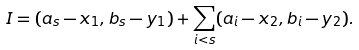<formula> <loc_0><loc_0><loc_500><loc_500>I = ( a _ { s } - x _ { 1 } , b _ { s } - y _ { 1 } ) + \sum _ { i < s } ( a _ { i } - x _ { 2 } , b _ { i } - y _ { 2 } ) .</formula> 